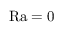Convert formula to latex. <formula><loc_0><loc_0><loc_500><loc_500>R a = 0</formula> 